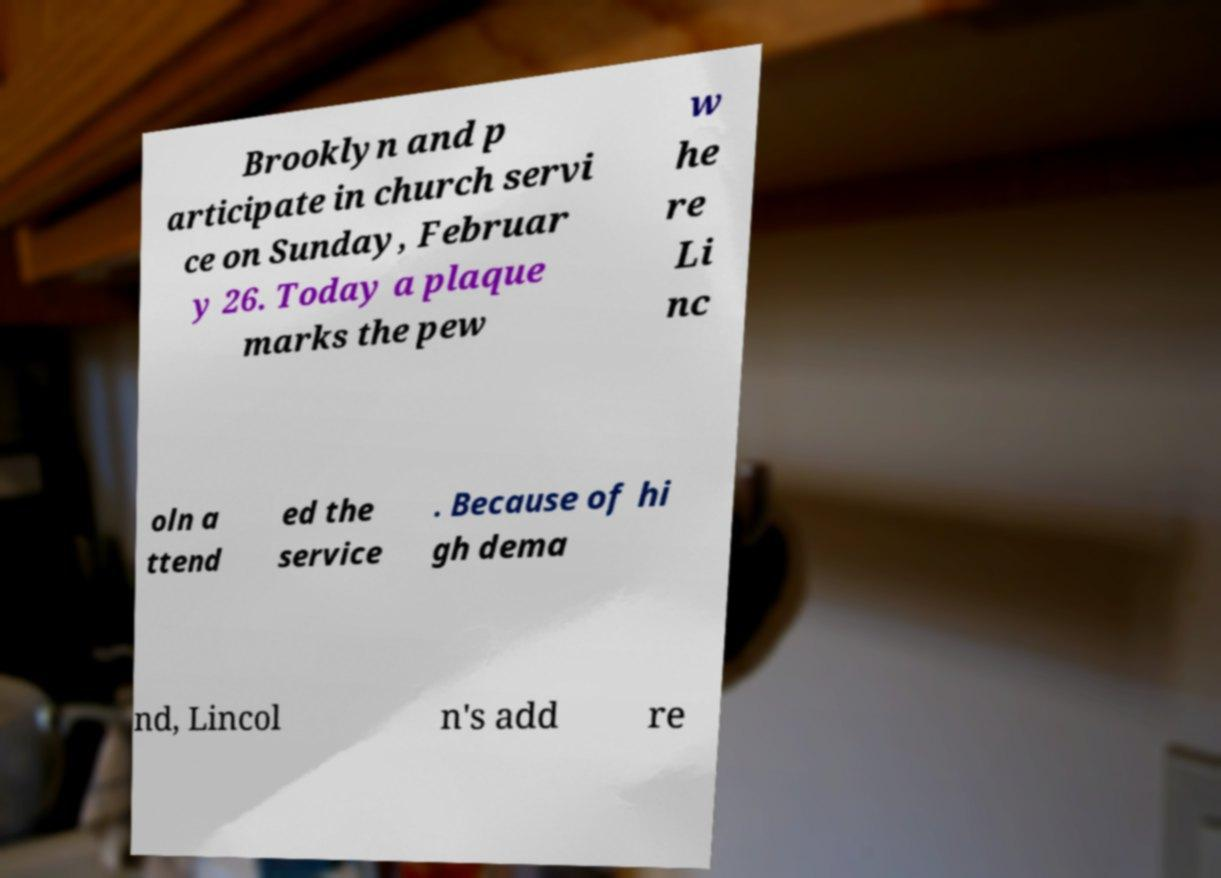Can you read and provide the text displayed in the image?This photo seems to have some interesting text. Can you extract and type it out for me? Brooklyn and p articipate in church servi ce on Sunday, Februar y 26. Today a plaque marks the pew w he re Li nc oln a ttend ed the service . Because of hi gh dema nd, Lincol n's add re 